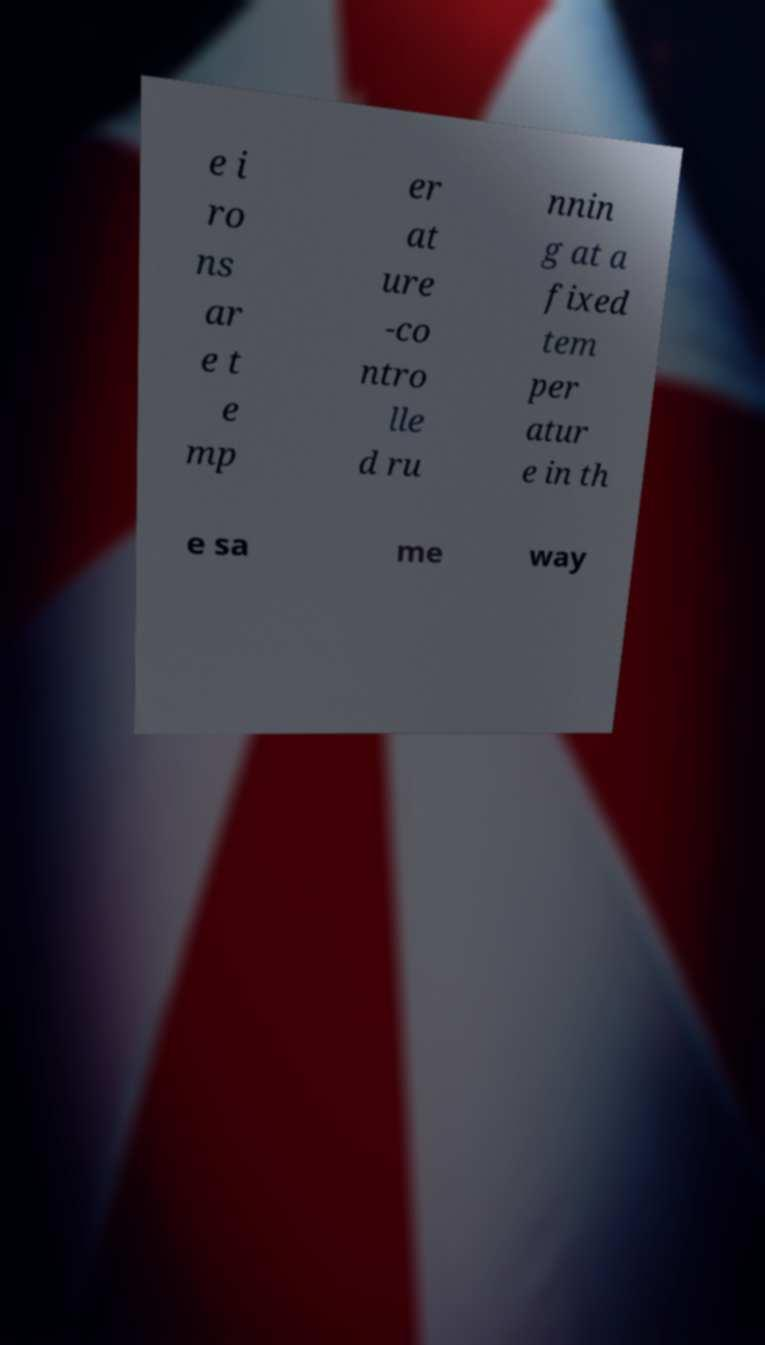Please read and relay the text visible in this image. What does it say? e i ro ns ar e t e mp er at ure -co ntro lle d ru nnin g at a fixed tem per atur e in th e sa me way 